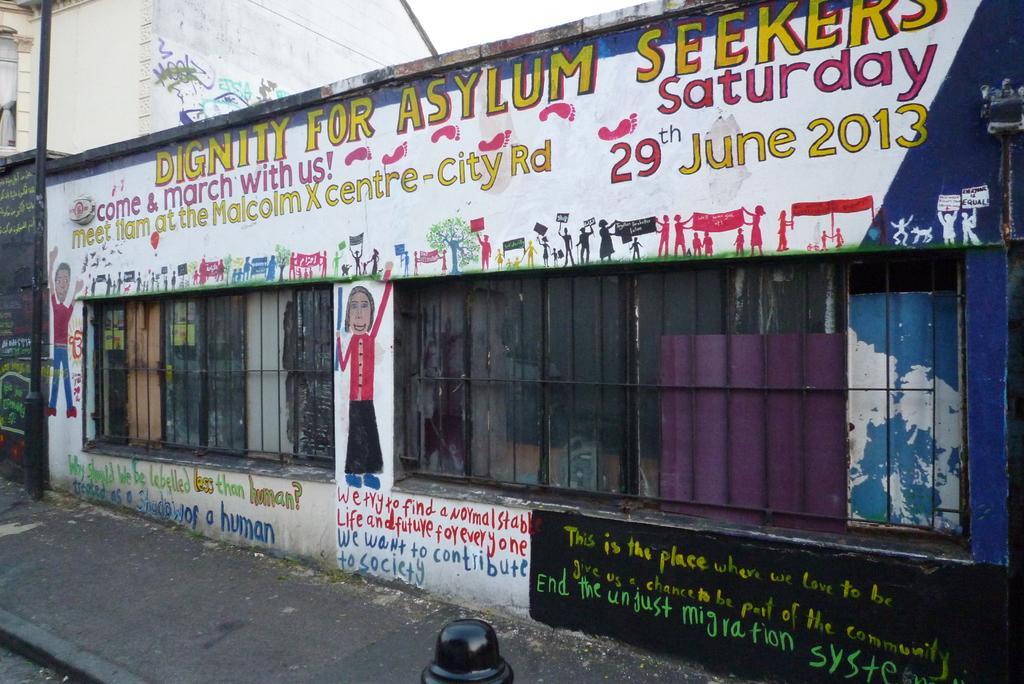How would you summarize this image in a sentence or two? In this image we can see a few buildings and on the wall we can see some text and paintings. We can see the pavement and to the side there is a pole. 